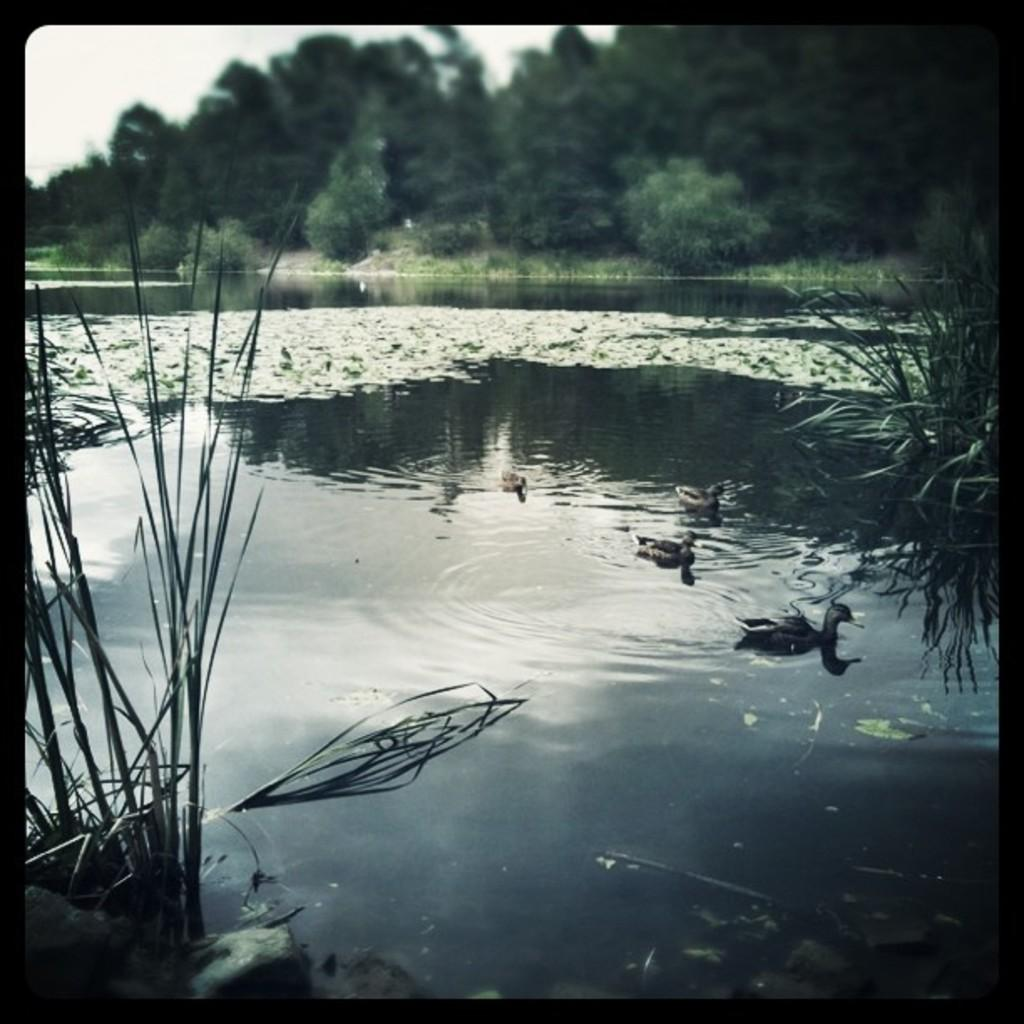What is the main subject in the center of the image? There is water in the center of the image. What animals can be seen on the water? There are ducks on the water. What type of vegetation is visible at the top side of the image? There are trees at the top side of the image. What other type of vegetation is present in the image? There are plants in the image. Where is the yak located in the image? There is no yak present in the image. What type of tool is being used to end the ducks' swimming session in the image? There is no tool or action depicted in the image that would end the ducks' swimming session. 